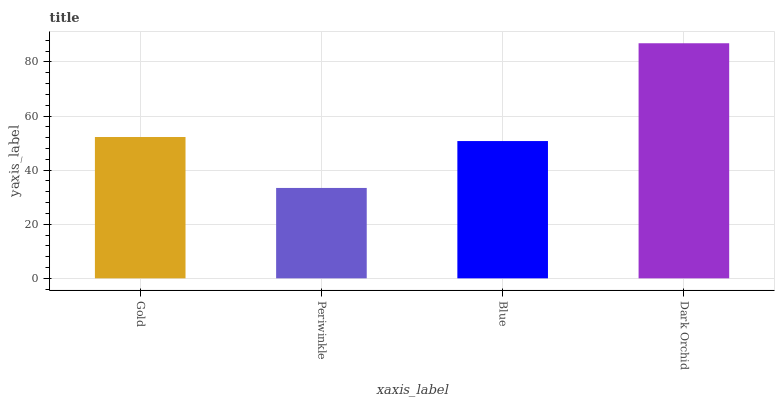Is Blue the minimum?
Answer yes or no. No. Is Blue the maximum?
Answer yes or no. No. Is Blue greater than Periwinkle?
Answer yes or no. Yes. Is Periwinkle less than Blue?
Answer yes or no. Yes. Is Periwinkle greater than Blue?
Answer yes or no. No. Is Blue less than Periwinkle?
Answer yes or no. No. Is Gold the high median?
Answer yes or no. Yes. Is Blue the low median?
Answer yes or no. Yes. Is Blue the high median?
Answer yes or no. No. Is Gold the low median?
Answer yes or no. No. 